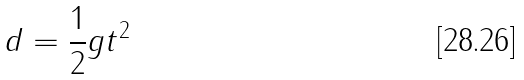<formula> <loc_0><loc_0><loc_500><loc_500>d = \frac { 1 } { 2 } g t ^ { 2 }</formula> 